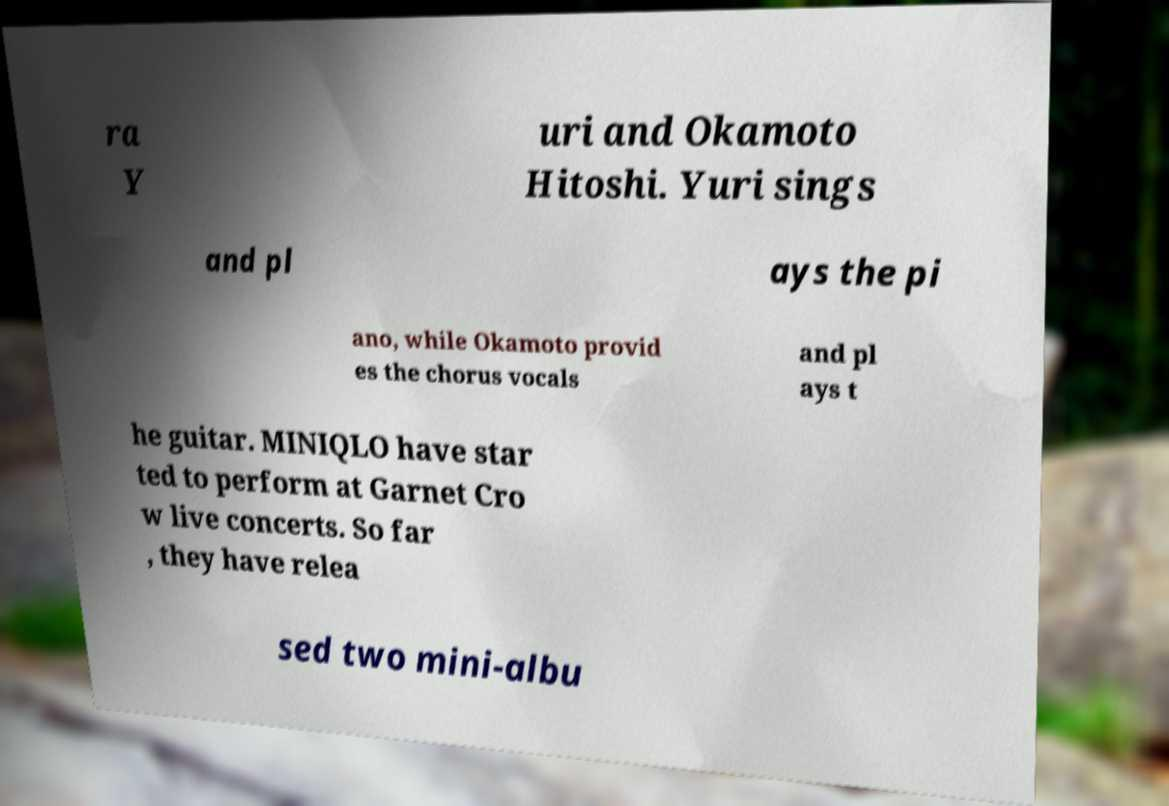Please read and relay the text visible in this image. What does it say? ra Y uri and Okamoto Hitoshi. Yuri sings and pl ays the pi ano, while Okamoto provid es the chorus vocals and pl ays t he guitar. MINIQLO have star ted to perform at Garnet Cro w live concerts. So far , they have relea sed two mini-albu 